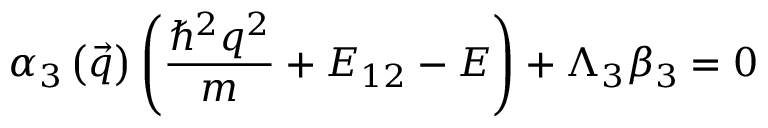<formula> <loc_0><loc_0><loc_500><loc_500>\alpha _ { 3 } \left ( \vec { q } \right ) \left ( \frac { \hbar { ^ } { 2 } q ^ { 2 } } { m } + E _ { 1 2 } - E \right ) + \Lambda _ { 3 } \beta _ { 3 } = 0</formula> 